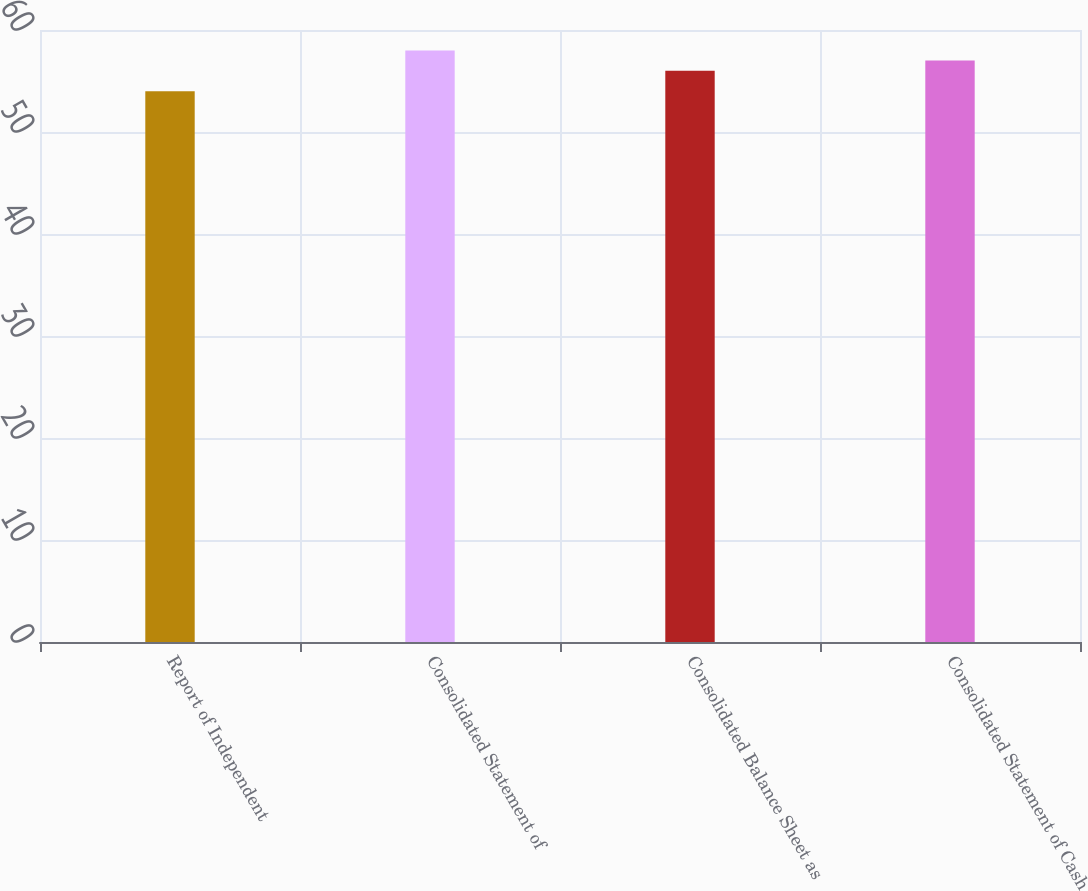Convert chart. <chart><loc_0><loc_0><loc_500><loc_500><bar_chart><fcel>Report of Independent<fcel>Consolidated Statement of<fcel>Consolidated Balance Sheet as<fcel>Consolidated Statement of Cash<nl><fcel>54<fcel>58<fcel>56<fcel>57<nl></chart> 